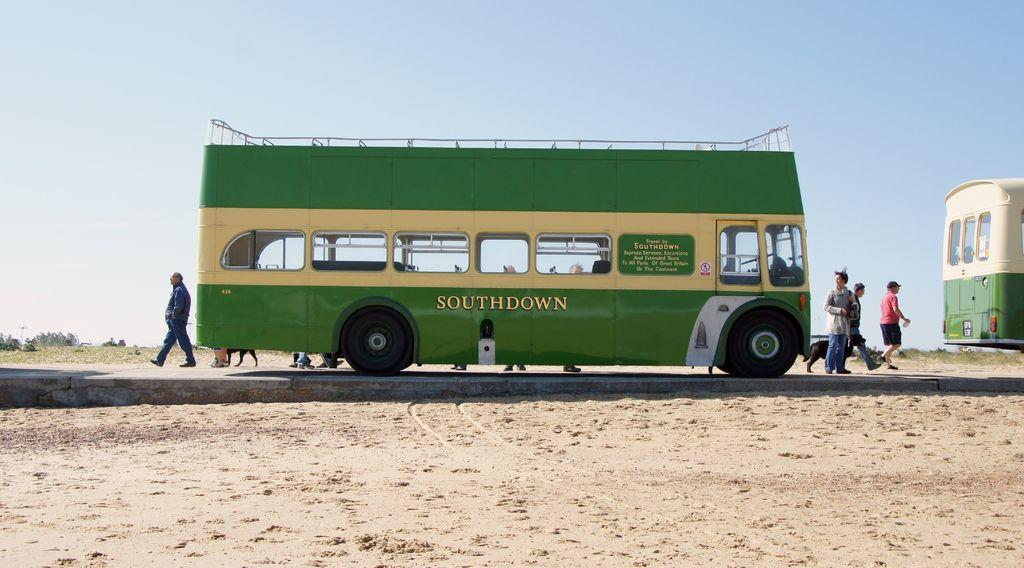<image>
Relay a brief, clear account of the picture shown. A green Southdown bus is on a road surrounded by sand. 